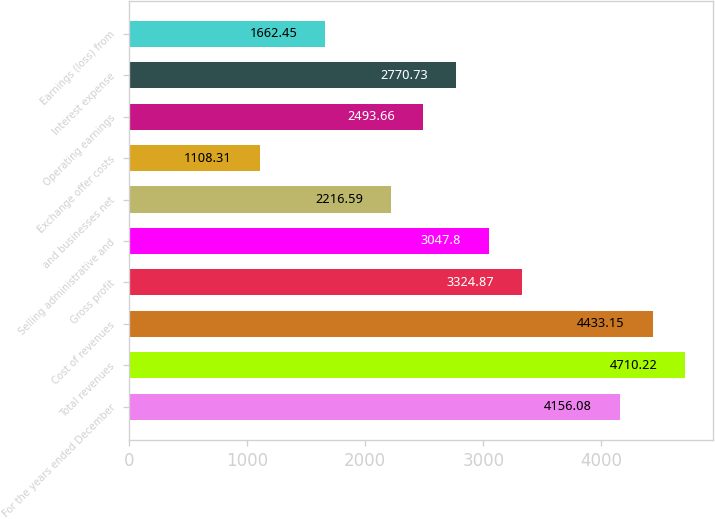Convert chart. <chart><loc_0><loc_0><loc_500><loc_500><bar_chart><fcel>For the years ended December<fcel>Total revenues<fcel>Cost of revenues<fcel>Gross profit<fcel>Selling administrative and<fcel>and businesses net<fcel>Exchange offer costs<fcel>Operating earnings<fcel>Interest expense<fcel>Earnings (loss) from<nl><fcel>4156.08<fcel>4710.22<fcel>4433.15<fcel>3324.87<fcel>3047.8<fcel>2216.59<fcel>1108.31<fcel>2493.66<fcel>2770.73<fcel>1662.45<nl></chart> 